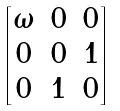<formula> <loc_0><loc_0><loc_500><loc_500>\begin{bmatrix} \omega & 0 & 0 \\ 0 & 0 & 1 \\ 0 & 1 & 0 \\ \end{bmatrix}</formula> 